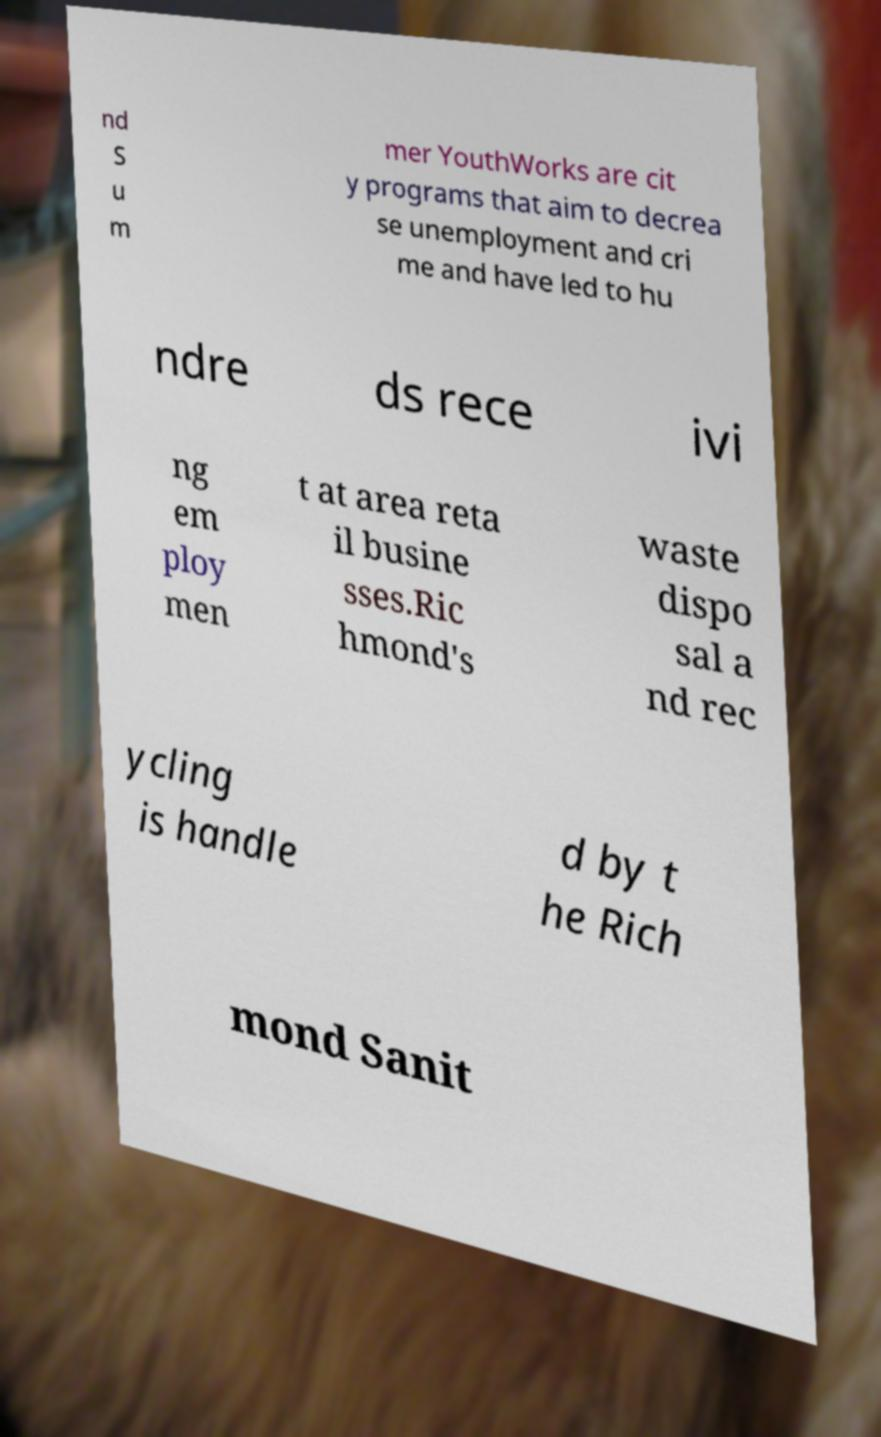There's text embedded in this image that I need extracted. Can you transcribe it verbatim? nd S u m mer YouthWorks are cit y programs that aim to decrea se unemployment and cri me and have led to hu ndre ds rece ivi ng em ploy men t at area reta il busine sses.Ric hmond's waste dispo sal a nd rec ycling is handle d by t he Rich mond Sanit 